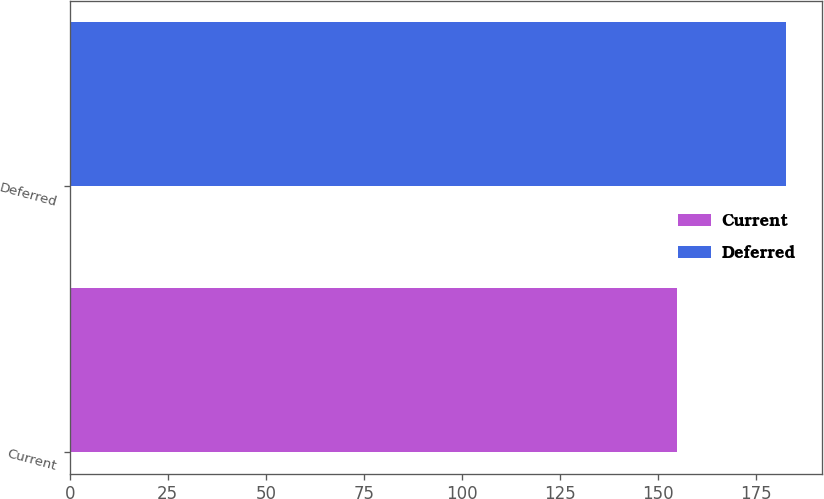<chart> <loc_0><loc_0><loc_500><loc_500><bar_chart><fcel>Current<fcel>Deferred<nl><fcel>154.9<fcel>182.7<nl></chart> 